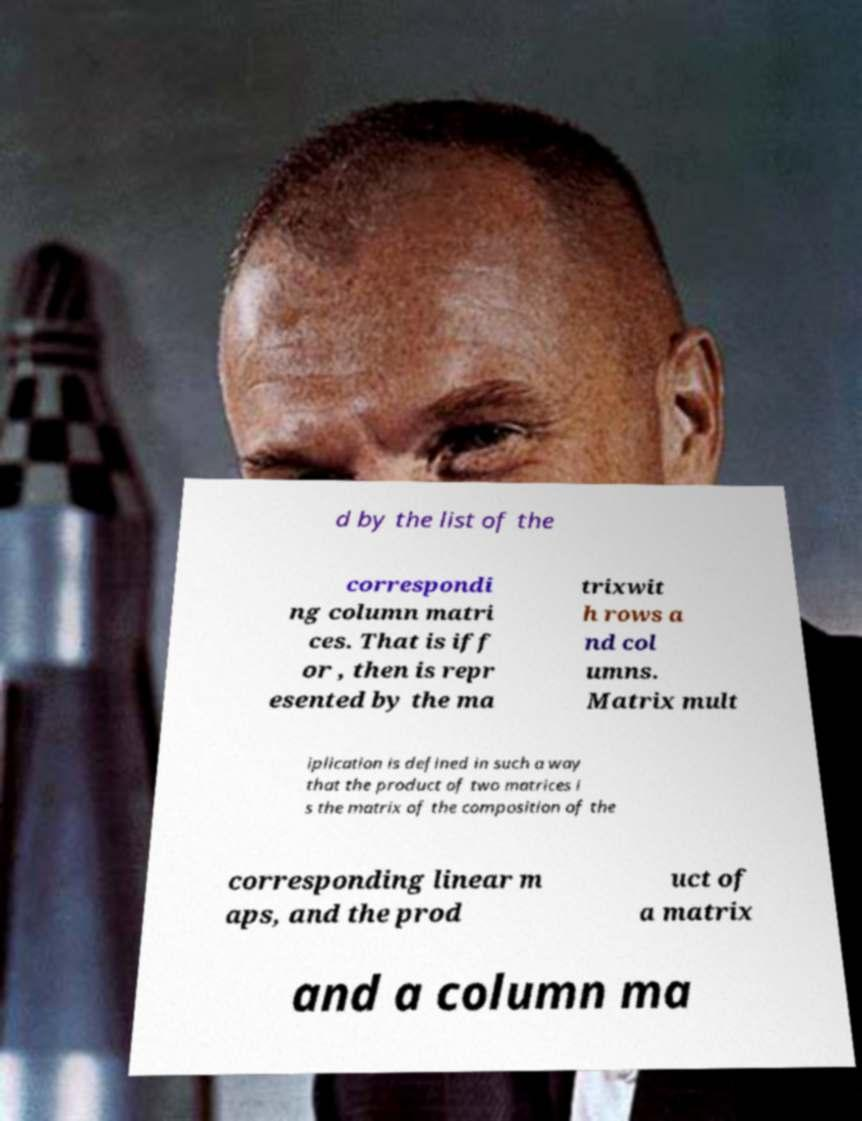Can you read and provide the text displayed in the image?This photo seems to have some interesting text. Can you extract and type it out for me? d by the list of the correspondi ng column matri ces. That is iff or , then is repr esented by the ma trixwit h rows a nd col umns. Matrix mult iplication is defined in such a way that the product of two matrices i s the matrix of the composition of the corresponding linear m aps, and the prod uct of a matrix and a column ma 